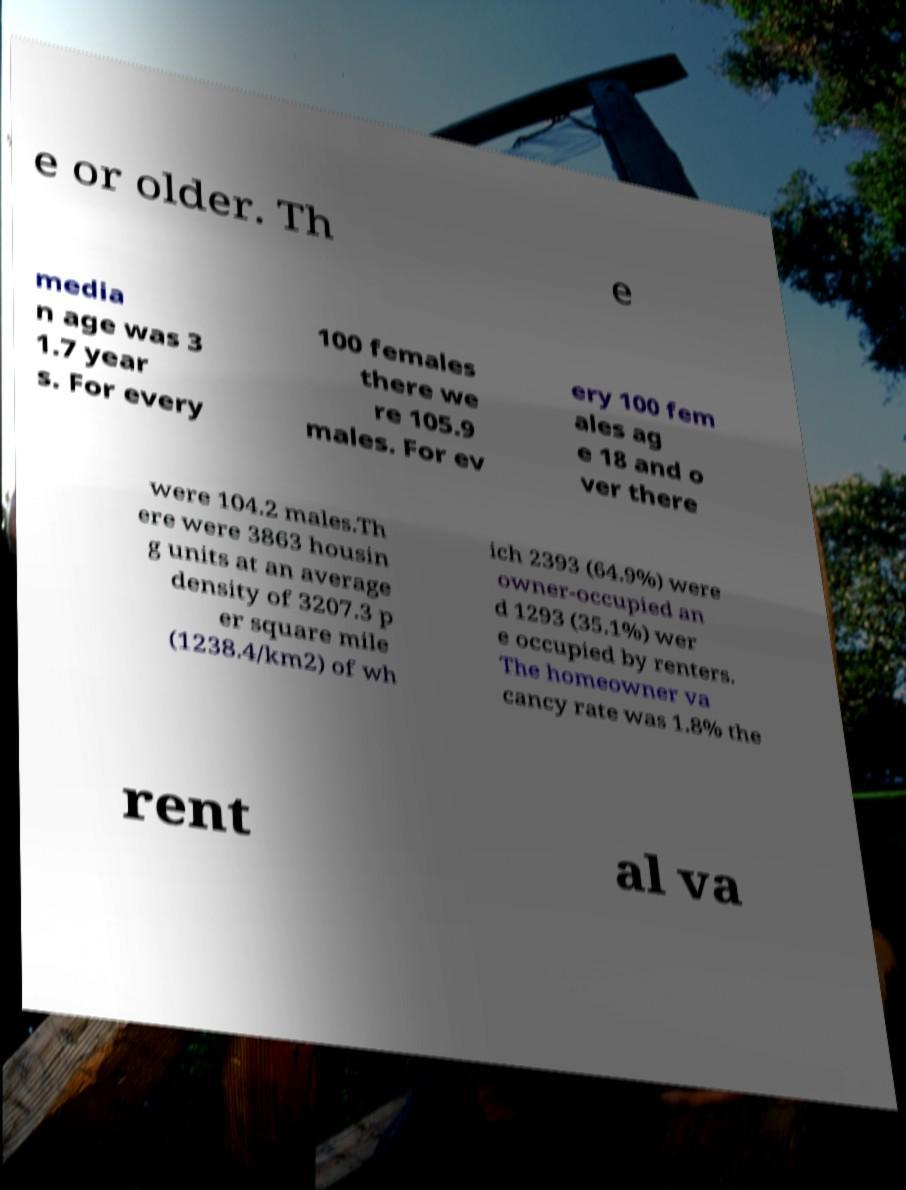There's text embedded in this image that I need extracted. Can you transcribe it verbatim? e or older. Th e media n age was 3 1.7 year s. For every 100 females there we re 105.9 males. For ev ery 100 fem ales ag e 18 and o ver there were 104.2 males.Th ere were 3863 housin g units at an average density of 3207.3 p er square mile (1238.4/km2) of wh ich 2393 (64.9%) were owner-occupied an d 1293 (35.1%) wer e occupied by renters. The homeowner va cancy rate was 1.8% the rent al va 